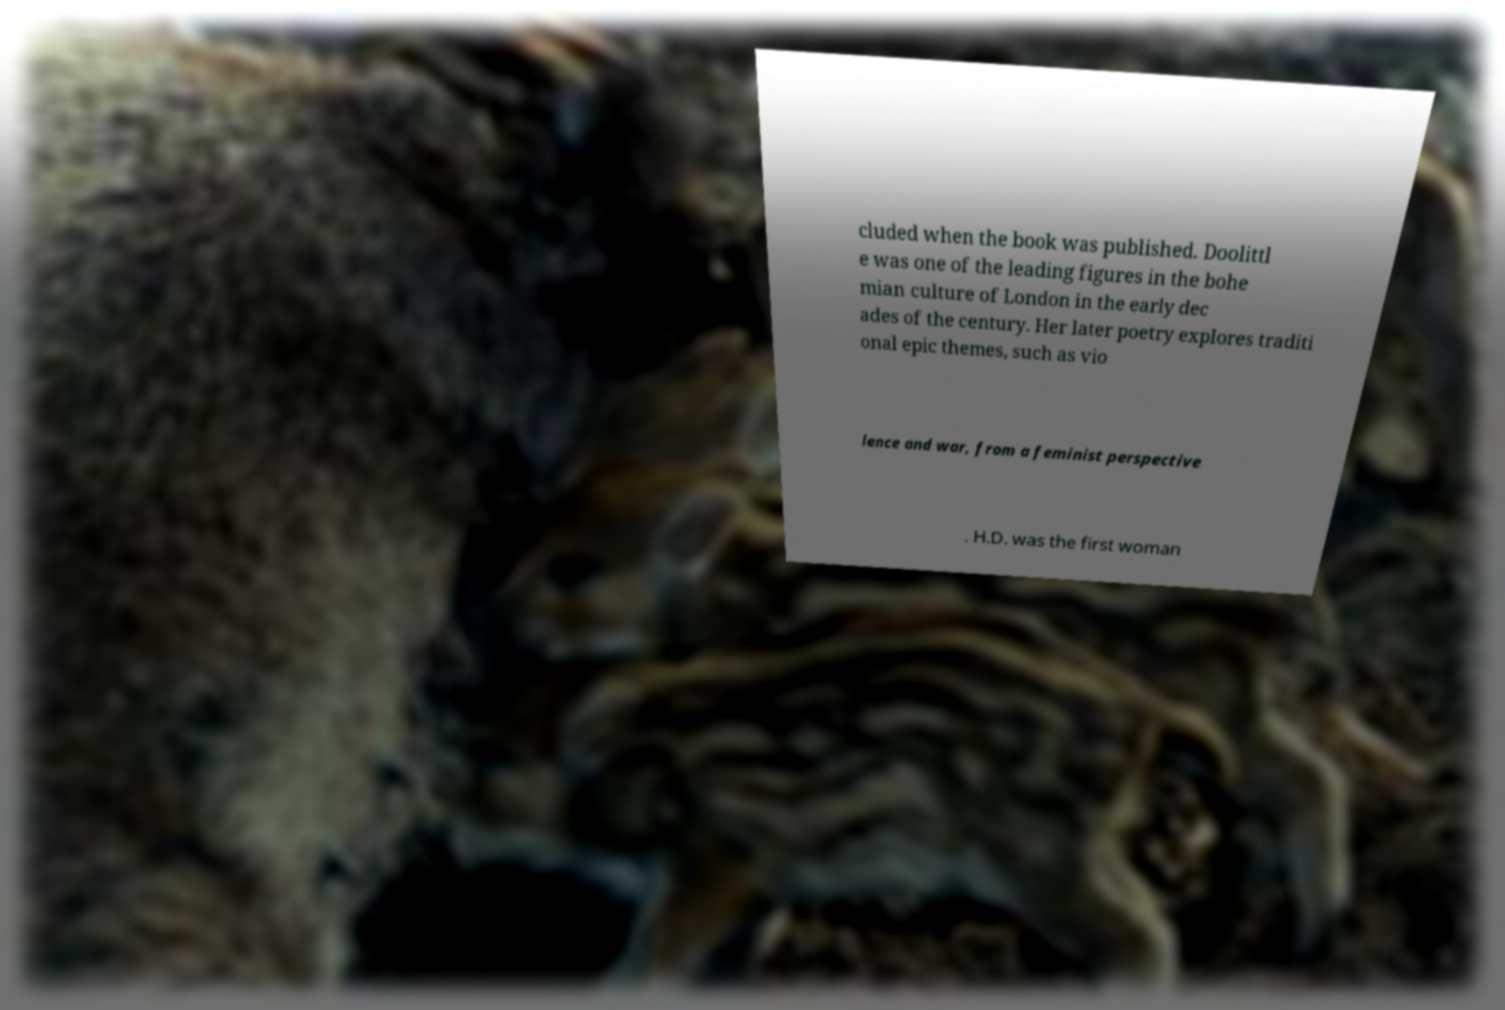Could you extract and type out the text from this image? cluded when the book was published. Doolittl e was one of the leading figures in the bohe mian culture of London in the early dec ades of the century. Her later poetry explores traditi onal epic themes, such as vio lence and war, from a feminist perspective . H.D. was the first woman 